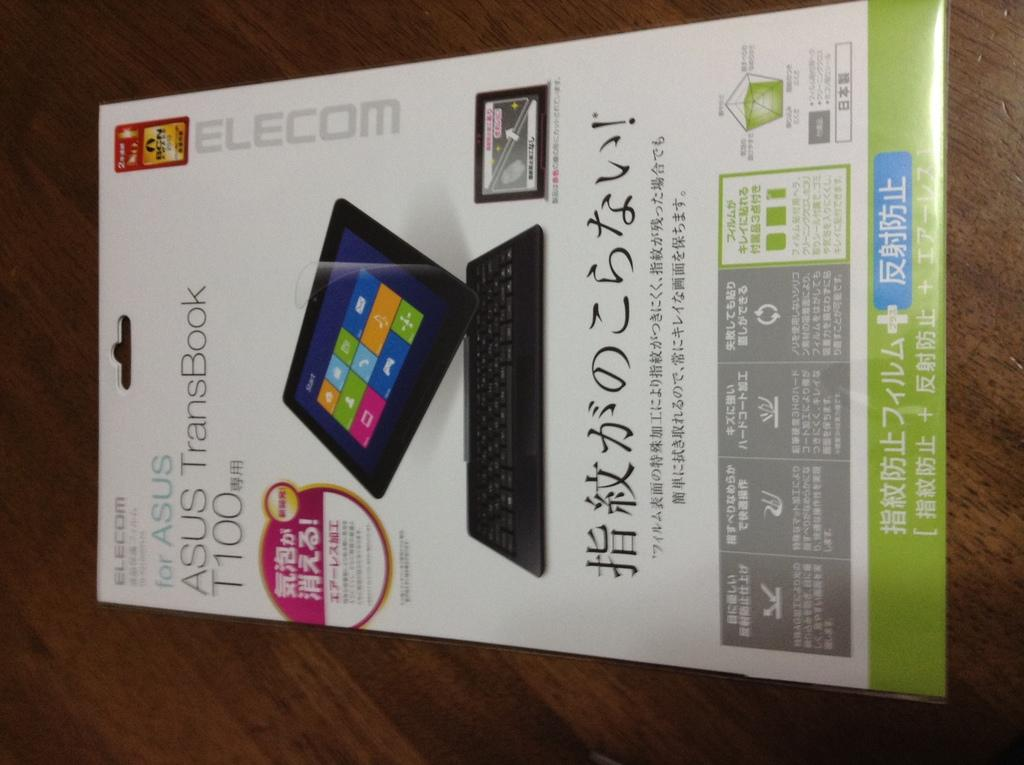What is present on the table in the image? There is a poster on the table in the image. How many boys are visible in the image? There is no boy present in the image; it only features a poster on a table. 